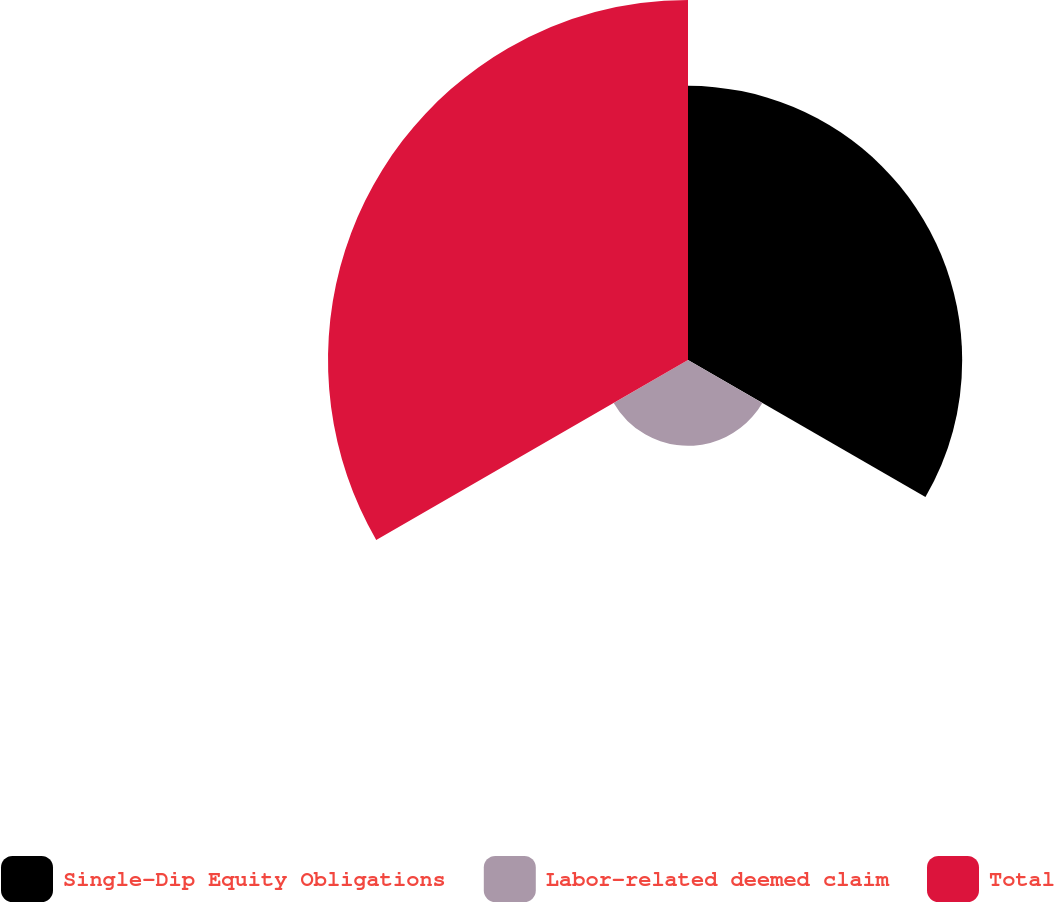<chart> <loc_0><loc_0><loc_500><loc_500><pie_chart><fcel>Single-Dip Equity Obligations<fcel>Labor-related deemed claim<fcel>Total<nl><fcel>38.08%<fcel>11.92%<fcel>50.0%<nl></chart> 